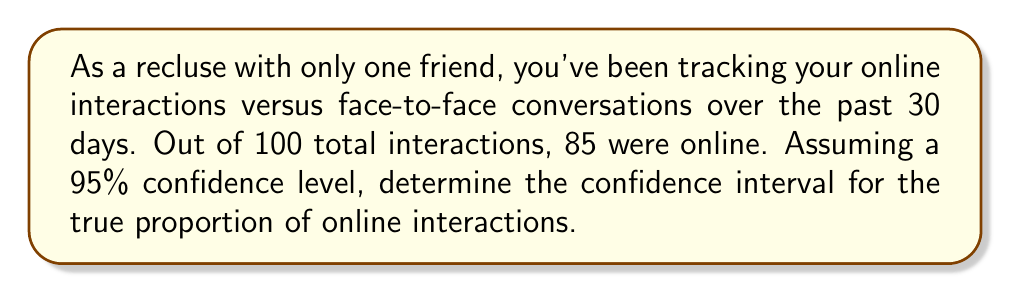Solve this math problem. Let's approach this step-by-step:

1) We're dealing with a proportion, so we'll use the formula for the confidence interval of a proportion:

   $$p \pm z\sqrt{\frac{p(1-p)}{n}}$$

   Where:
   $p$ = sample proportion
   $z$ = z-score for the desired confidence level
   $n$ = sample size

2) Given:
   - Sample proportion (p) = 85/100 = 0.85
   - Sample size (n) = 100
   - Confidence level = 95% (z-score = 1.96)

3) Let's plug these values into our formula:

   $$0.85 \pm 1.96\sqrt{\frac{0.85(1-0.85)}{100}}$$

4) Simplify inside the square root:

   $$0.85 \pm 1.96\sqrt{\frac{0.85(0.15)}{100}}$$

5) Calculate:

   $$0.85 \pm 1.96\sqrt{0.001275}$$
   $$0.85 \pm 1.96(0.0357)$$
   $$0.85 \pm 0.07$$

6) Therefore, the confidence interval is:

   $$(0.85 - 0.07, 0.85 + 0.07)$$
   $$(0.78, 0.92)$$

This means we can be 95% confident that the true proportion of online interactions falls between 0.78 (78%) and 0.92 (92%).
Answer: (0.78, 0.92) 